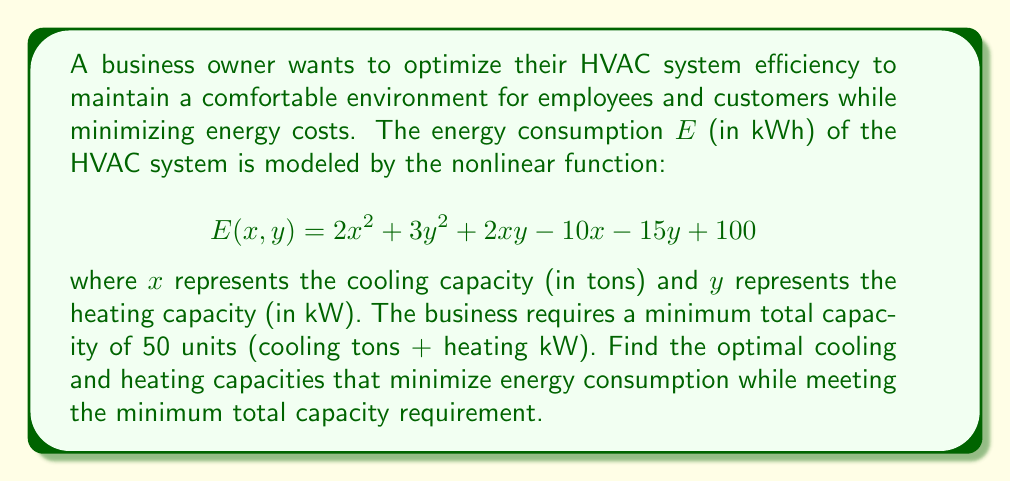Solve this math problem. To solve this nonlinear programming problem, we'll use the method of Lagrange multipliers:

1) Define the objective function:
   $$E(x, y) = 2x^2 + 3y^2 + 2xy - 10x - 15y + 100$$

2) Define the constraint:
   $$g(x, y) = x + y - 50 = 0$$

3) Form the Lagrangian function:
   $$L(x, y, \lambda) = E(x, y) - \lambda g(x, y)$$
   $$L(x, y, \lambda) = 2x^2 + 3y^2 + 2xy - 10x - 15y + 100 - \lambda(x + y - 50)$$

4) Take partial derivatives and set them to zero:
   $$\frac{\partial L}{\partial x} = 4x + 2y - 10 - \lambda = 0$$
   $$\frac{\partial L}{\partial y} = 2x + 6y - 15 - \lambda = 0$$
   $$\frac{\partial L}{\partial \lambda} = -(x + y - 50) = 0$$

5) Solve the system of equations:
   From the third equation: $x + y = 50$
   Subtracting the first equation from the second:
   $$2x + 6y - 15 - \lambda = 4x + 2y - 10 - \lambda$$
   $$4y = 2x + 5$$
   $$y = \frac{x}{2} + \frac{5}{4}$$

   Substituting into $x + y = 50$:
   $$x + (\frac{x}{2} + \frac{5}{4}) = 50$$
   $$\frac{3x}{2} + \frac{5}{4} = 50$$
   $$3x + \frac{5}{2} = 100$$
   $$3x = \frac{195}{2}$$
   $$x = 32.5$$

   Then, $y = 50 - 32.5 = 17.5$

6) Verify the solution satisfies the constraint:
   $32.5 + 17.5 = 50$, which meets the minimum total capacity requirement.
Answer: Optimal cooling capacity: 32.5 tons; Optimal heating capacity: 17.5 kW 